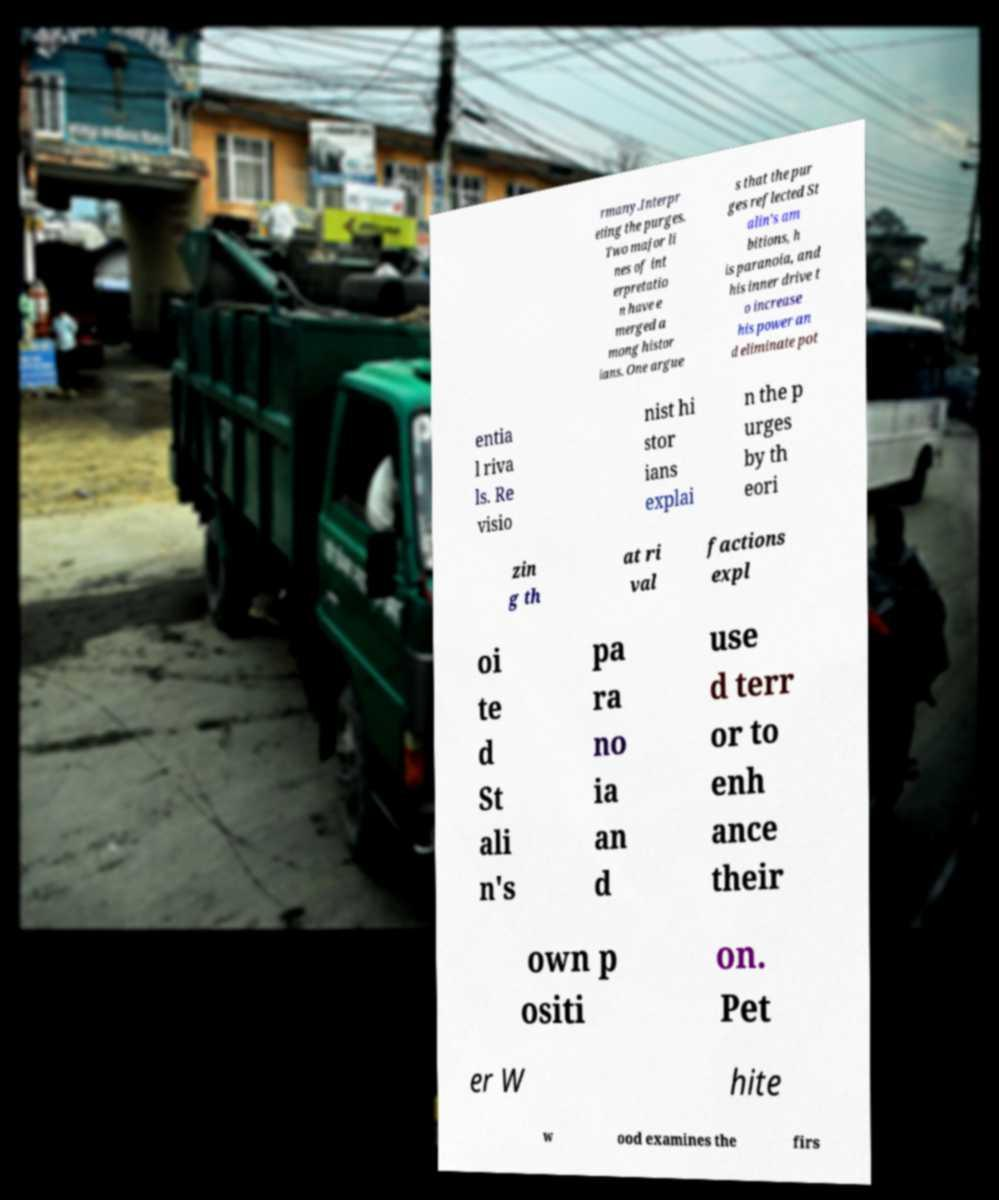Could you extract and type out the text from this image? rmany.Interpr eting the purges. Two major li nes of int erpretatio n have e merged a mong histor ians. One argue s that the pur ges reflected St alin's am bitions, h is paranoia, and his inner drive t o increase his power an d eliminate pot entia l riva ls. Re visio nist hi stor ians explai n the p urges by th eori zin g th at ri val factions expl oi te d St ali n's pa ra no ia an d use d terr or to enh ance their own p ositi on. Pet er W hite w ood examines the firs 